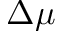<formula> <loc_0><loc_0><loc_500><loc_500>\Delta \mu</formula> 